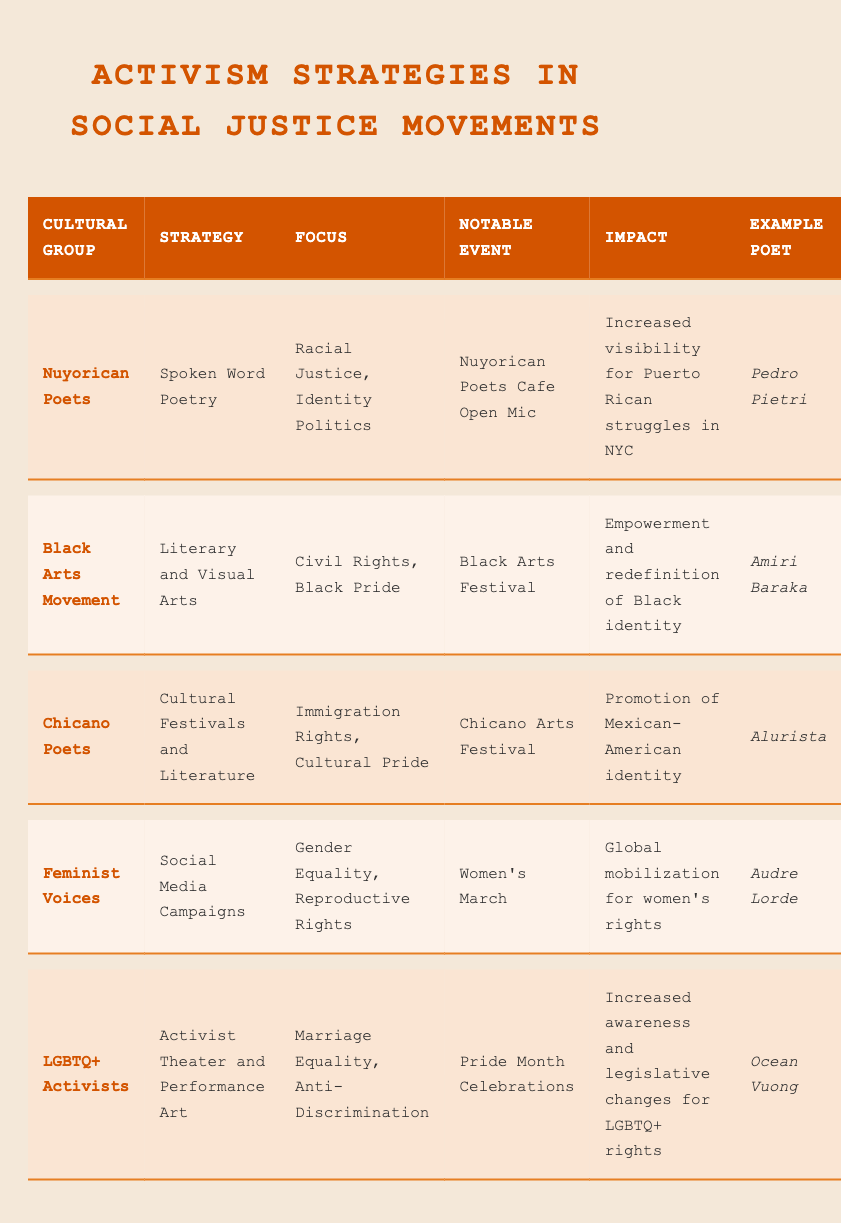What activism strategy is used by Nuyorican poets? From the table, under the "Strategy" column corresponding to "Nuyorican Poets," it is listed as "Spoken Word Poetry."
Answer: Spoken Word Poetry Which cultural group focuses on Gender Equality and Reproductive Rights? By examining the "Focus" column, we find that "Feminist Voices" is the only group that explicitly mentions "Gender Equality, Reproductive Rights."
Answer: Feminist Voices What notable event is associated with the Black Arts Movement? Looking at the "Notable Event" column for the "Black Arts Movement," it states "Black Arts Festival."
Answer: Black Arts Festival Is Pedro Pietri an example poet for Chicano Poets? The table shows that Pedro Pietri is listed as the example poet under "Nuyorican Poets," not "Chicano Poets," which lists Alurista instead. Hence, the statement is false.
Answer: No How many cultural groups focus on issues related to identity or cultural pride? Scanning the table for the "Focus" column, both "Nuyorican Poets" and "Chicano Poets" focus on identity or cultural pride, giving us a total of two groups.
Answer: 2 Which activism strategy appears most frequently in the table? By reviewing the strategies listed in the table, "Literary and Visual Arts" and "Social Media Campaigns" each appear once, while "Spoken Word Poetry," "Cultural Festivals and Literature," and "Activist Theater and Performance Art" also appear once. Hence, each strategy is unique in this context, indicating no single recurring strategy.
Answer: None recurring What is the impact of the women's march according to the table? The "Impact" column for the "Feminist Voices" entry states "Global mobilization for women’s rights," which summarizes the impact of the Women's March effectively.
Answer: Global mobilization for women’s rights Which cultural group employs cultural festivals as a strategy? The table indicates that "Chicano Poets" utilize "Cultural Festivals and Literature" as their strategy, clearly identified in the "Strategy" column.
Answer: Chicano Poets Is Ocean Vuong listed as an example poet for the LGBTQ+ Activist group? The table confirms that Ocean Vuong is indeed listed as the example poet under the "LGBTQ+ Activists" category, affirming the statement is true.
Answer: Yes 